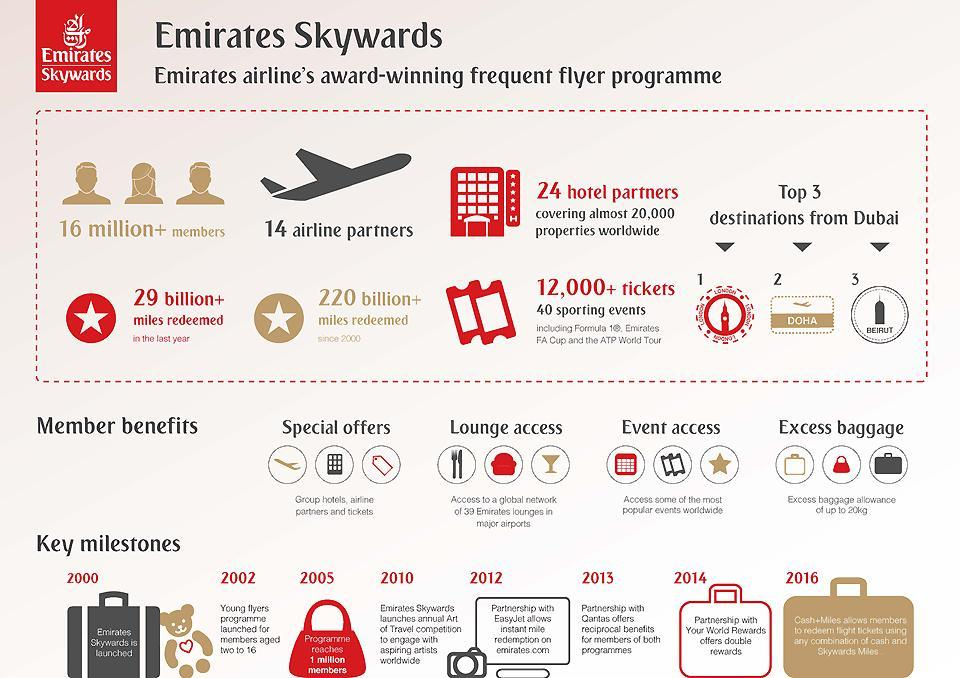How many miles have been redeemed since 2000
Answer the question with a short phrase. 220 billion+ for whom is the young flyers programme for members aged two to 16 how many member benefits have been shown 4 When was Emirates Skywards launched 2000 Which are the top 3 destinations from Dubai for Emirates Airlines London, Doha, Beirut what is written on the red bag programme reaches 1 million members What does partnership with Easy Jet allow instant mile redemption on emirates com 24 hotel partners include how many properties almost 20,000 